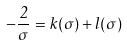Convert formula to latex. <formula><loc_0><loc_0><loc_500><loc_500>- \frac { 2 } { \sigma } = k ( \sigma ) + l ( \sigma )</formula> 